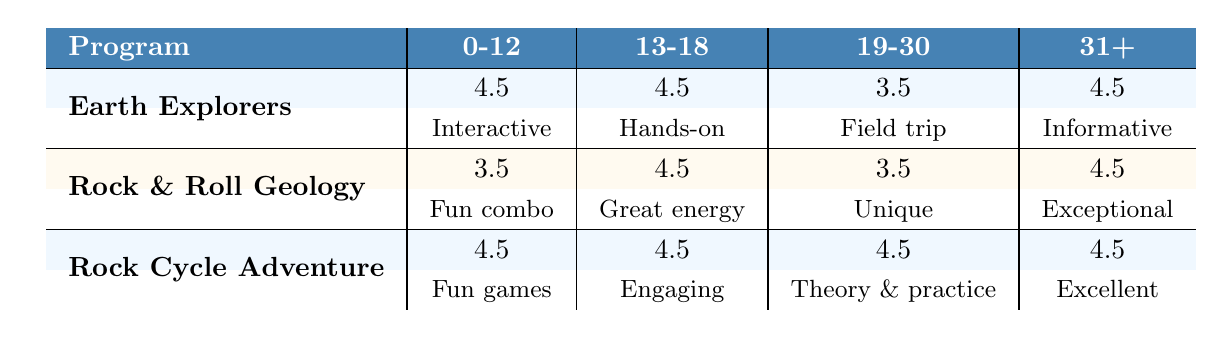What is the highest average rating for any age group across all geology programs? To find the highest average rating, we need to look at all the average ratings for each program and age group. The average ratings from the table are: Earth Explorers (4.5, 4.5, 3.5, 4.5), Rock & Roll Geology (3.5, 4.5, 3.5, 4.5), Rock Cycle Adventure (4.5, 4.5, 4.5, 4.5). The maximum value is 4.5 which appears in all age groups for Earth Explorers and Rock Cycle Adventure.
Answer: 4.5 Which program received the lowest average rating in the 19-30 age group? In the 19-30 age group, we check the average ratings for all programs. The ratings are: Earth Explorers (3.5), Rock & Roll Geology (3.5), and Rock Cycle Adventure (4.5). Both Earth Explorers and Rock & Roll Geology have the same lowest average rating of 3.5, making them tied for the lowest in this age group.
Answer: 3.5 Did the program "Rock Cycle Adventure" receive a higher average rating from age group 0-12 or 31+? The average rating for Rock Cycle Adventure in the 0-12 age group is 4.5, and in the 31+ age group is also 4.5. Since both ratings are equal, the answer is that they are the same, and neither is higher.
Answer: No, they are the same Which age group provided the best feedback for the "Earth Explorers" program? Looking at the average ratings for the Earth Explorers program: 0-12 (4.5), 13-18 (4.5), 19-30 (3.5), and 31+ (4.5). The age groups 0-12, 13-18, and 31+ all have the highest rating of 4.5, indicating they provided the best feedback. Since there are multiple groups, I will mention that 0-12, 13-18, and 31+ shared the best feedback.
Answer: 0-12, 13-18, 31+ Is the feedback for the "Rock & Roll Geology" program in the 13-18 age group higher than that in the 0-12 age group? The average rating for the Rock & Roll Geology in the 13-18 age group is 4.5, and for the 0-12 age group is 3.5. 4.5 is greater than 3.5, therefore the feedback in the 13-18 age group is higher than in the 0-12 age group.
Answer: Yes 